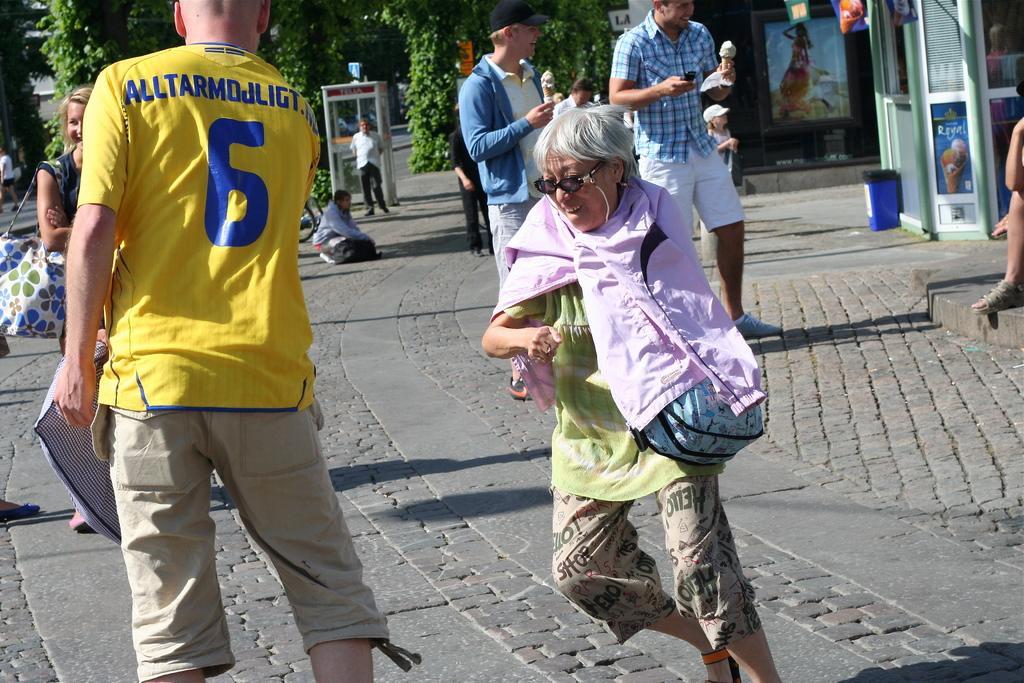Can you describe this image briefly? There are many people. Person in the front is holding a bag and wearing specs. Persons in the back is holding ice creams. Person on the left side is wearing a t shirt with a number and something written on that. In the background there are trees. On the right side there is a building and near to that there is a bin. 